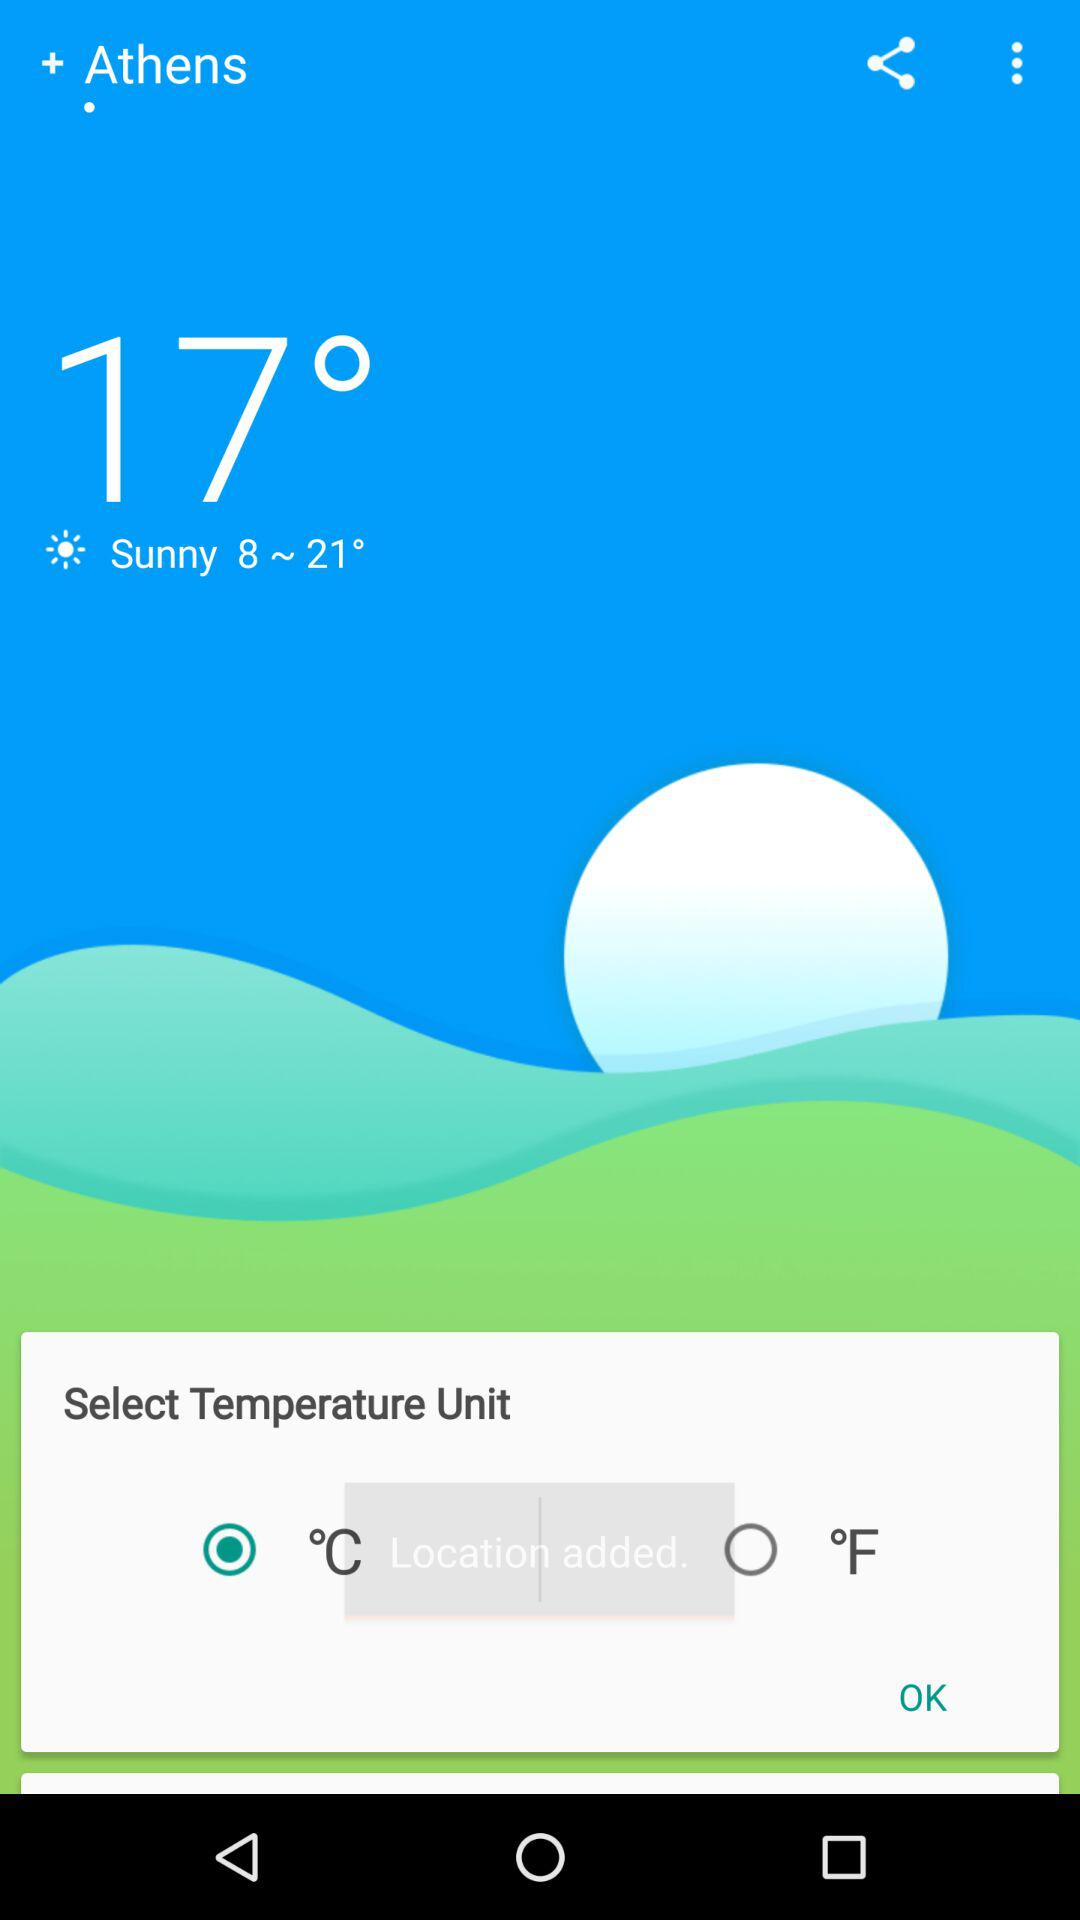What is the selected city? The selected city is Athens. 